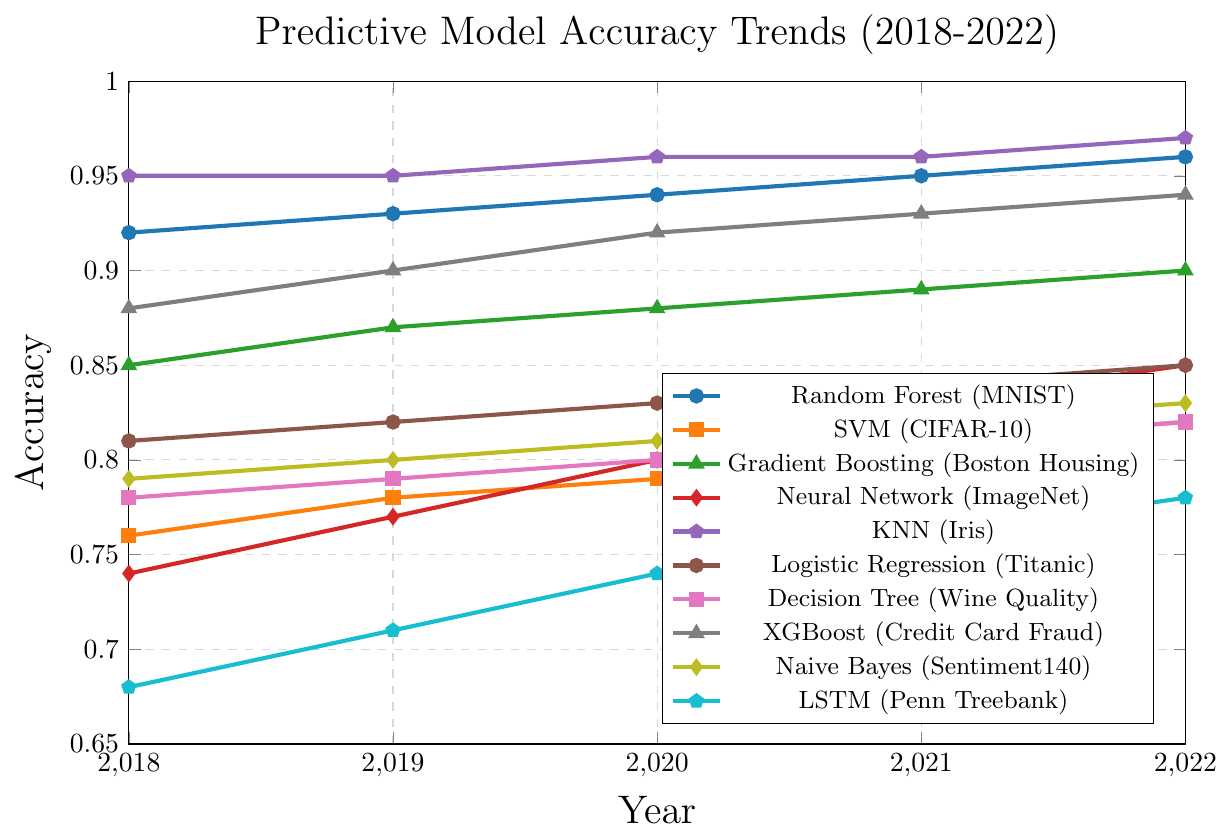Which algorithm shows the highest accuracy in 2022? Look at the highest point on the vertical axis for the year 2022 and notice the corresponding algorithm.
Answer: K-Nearest Neighbors (Iris) Which algorithm improved the most in accuracy from 2018 to 2022? Calculate the difference in accuracy between 2018 and 2022 for each algorithm, and find the algorithm with the largest increase.
Answer: Long Short-Term Memory (Penn Treebank) Which two algorithms had equal accuracy in any year, and in which year? Compare the accuracy values for all pairs of algorithms across each year to find any matches.
Answer: Support Vector Machine (CIFAR-10) and Decision Tree (Wine Quality) in 2022 What is the average accuracy of the Logistic Regression (Titanic) from 2018 to 2022? Sum the accuracies from 2018 to 2022 for Logistic Regression and then divide by the number of years (5). (0.81+0.82+0.83+0.84+0.85)/5 = 4.15/5 = 0.83
Answer: 0.83 Which algorithm has the steepest increase in accuracy between any two consecutive years? Calculate the differences in accuracy for all algorithms between each pair of consecutive years and find the largest increment.
Answer: Neural Network (ImageNet) from 2019 to 2020 Which algorithm had the lowest accuracy in 2018 and what was its value? Identify the lowest point on the vertical axis for the year 2018 and check the corresponding algorithm.
Answer: Long Short-Term Memory (Penn Treebank), 0.68 Which dataset's model accuracy follows a perfect linear trend? Identify an algorithm where the accuracy values increase consistently by the same amount each year.
Answer: Gradient Boosting (Boston Housing) What is the difference in accuracy between the Random Forest (MNIST) and the XGBoost (Credit Card Fraud) models in 2020? Subtract the accuracy of XGBoost in 2020 from that of Random Forest in the same year. (0.94 - 0.92)
Answer: 0.02 How many algorithms had an accuracy of at least 0.90 in 2022? Count the number of algorithms that reached or exceeded an accuracy of 0.90 in 2022.
Answer: 5 By how much did the accuracy of the Neural Network on ImageNet increase from 2018 to 2021? Subtract the accuracy of 2018 from 2021 for the Neural Network. (0.83 - 0.74)
Answer: 0.09 